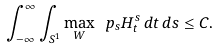<formula> <loc_0><loc_0><loc_500><loc_500>\int _ { - \infty } ^ { \infty } \int _ { S ^ { 1 } } \max _ { W } \ p _ { s } H ^ { s } _ { t } \, d t \, d s \leq C .</formula> 